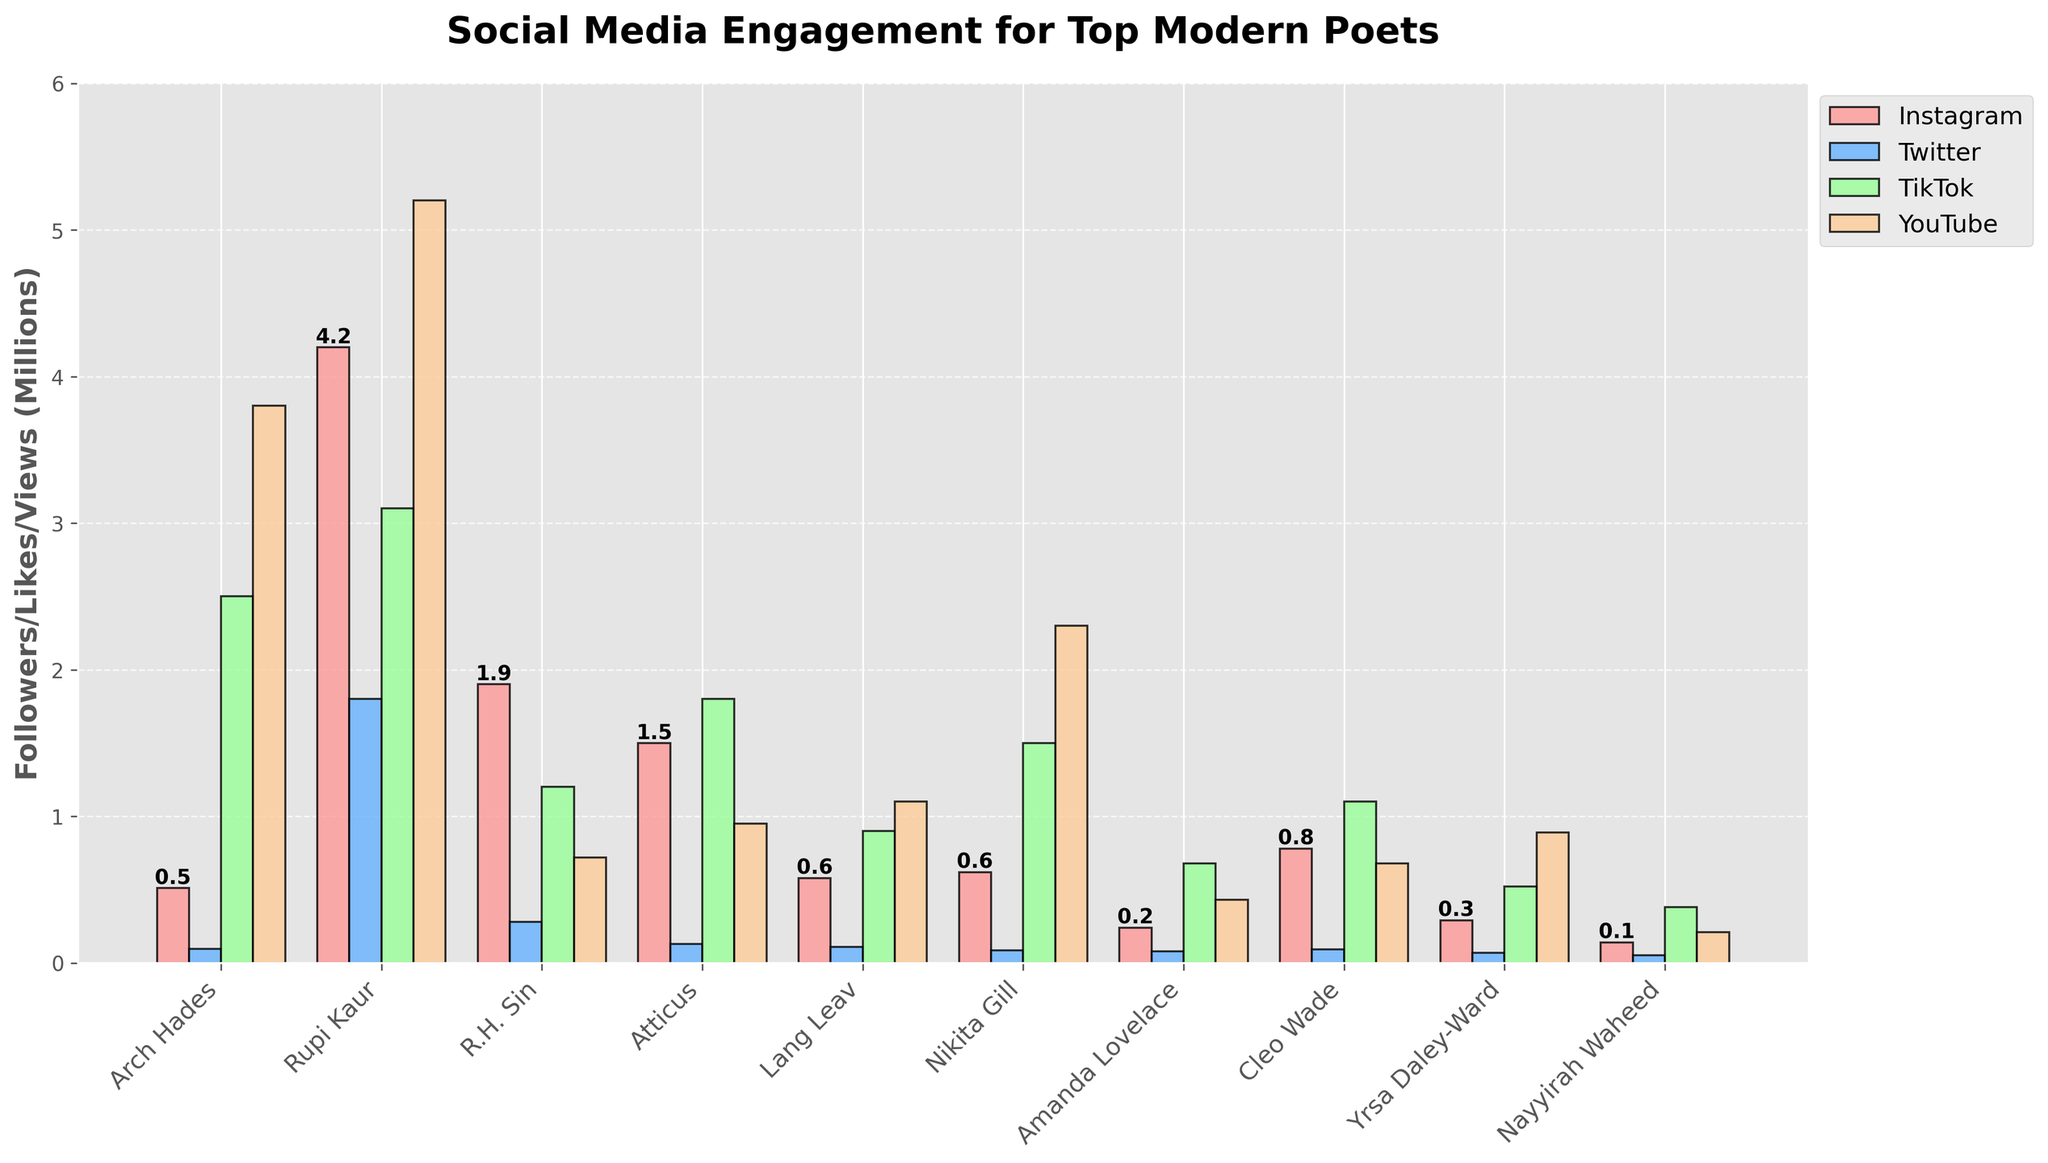Which poet has the highest number of Instagram followers? By observing the height of the red bars which represent Instagram followers, you can see that Rupi Kaur's bar is the tallest, indicating that she has the highest number of followers.
Answer: Rupi Kaur How do Arch Hades' TikTok likes compare to Amanda Lovelace's TikTok likes? By comparing the height of the green bars for TikTok likes, it is clear that Arch Hades' bar is significantly higher than Amanda Lovelace's, indicating that Arch Hades has more TikTok likes.
Answer: Arch Hades has more Which poet has the least YouTube views? By observing the height of the orange bars representing YouTube views, Nayyirah Waheed has the shortest bar, indicating the least number of YouTube views.
Answer: Nayyirah Waheed What is the total number of YouTube views (in millions) for Arch Hades, Nikita Gill, and Cleo Wade? The YouTube views in millions for Arch Hades, Nikita Gill, and Cleo Wade are 3.8, 2.3, and 0.68 respectively. Summing them up, 3.8 + 2.3 + 0.68 = 6.78.
Answer: 6.78 Which poet has more Twitter followers, Atticus or Lang Leav? By comparing the height of the blue bars for Twitter followers, it is apparent that Atticus has a slightly higher bar compared to Lang Leav.
Answer: Atticus Between Rupi Kaur and R.H. Sin, who has more overall social media engagement, taking into account Instagram followers, Twitter followers, TikTok likes, and YouTube views? Summing all engagement metrics for both poets: Rupi Kaur has 4.2 + 1.8 + 3.1 + 5.2 = 14.3 million overall engagement, while R.H. Sin has 1.9 + 0.28 + 1.2 + 0.72 = 4.1 million overall engagement.
Answer: Rupi Kaur How many poets have Instagram follower counts between 500,000 and 1,000,000? By counting the number of red bars whose height falls between 0.5 and 1 million on the y-axis, we find there are three poets: Lang Leav (0.58), Nikita Gill (0.62), and Cleo Wade (0.78).
Answer: 3 Which platform shows the most engagement for Yrsa Daley-Ward? By comparing the height of the bars representing different platforms for Yrsa Daley-Ward, Instagram followers (red), Twitter followers (blue), TikTok likes (green), and YouTube views (orange), the highest bar is for Instagram followers (0.29 million).
Answer: Instagram What is the average number of YouTube views (in millions) across all poets? Sum the YouTube views for all poets and divide by the number of poets: (3.8 + 5.2 + 0.72 + 0.95 + 1.1 + 2.3 + 0.43 + 0.68 + 0.89 + 0.21) / 10 = 1.728 million.
Answer: 1.728 Does Amanda Lovelace have more Instagram followers or more TikTok likes? By comparing the red bar (Instagram followers) and the green bar (TikTok likes) for Amanda Lovelace, the TikTok likes bar is visibly taller than the Instagram followers bar.
Answer: More TikTok likes 